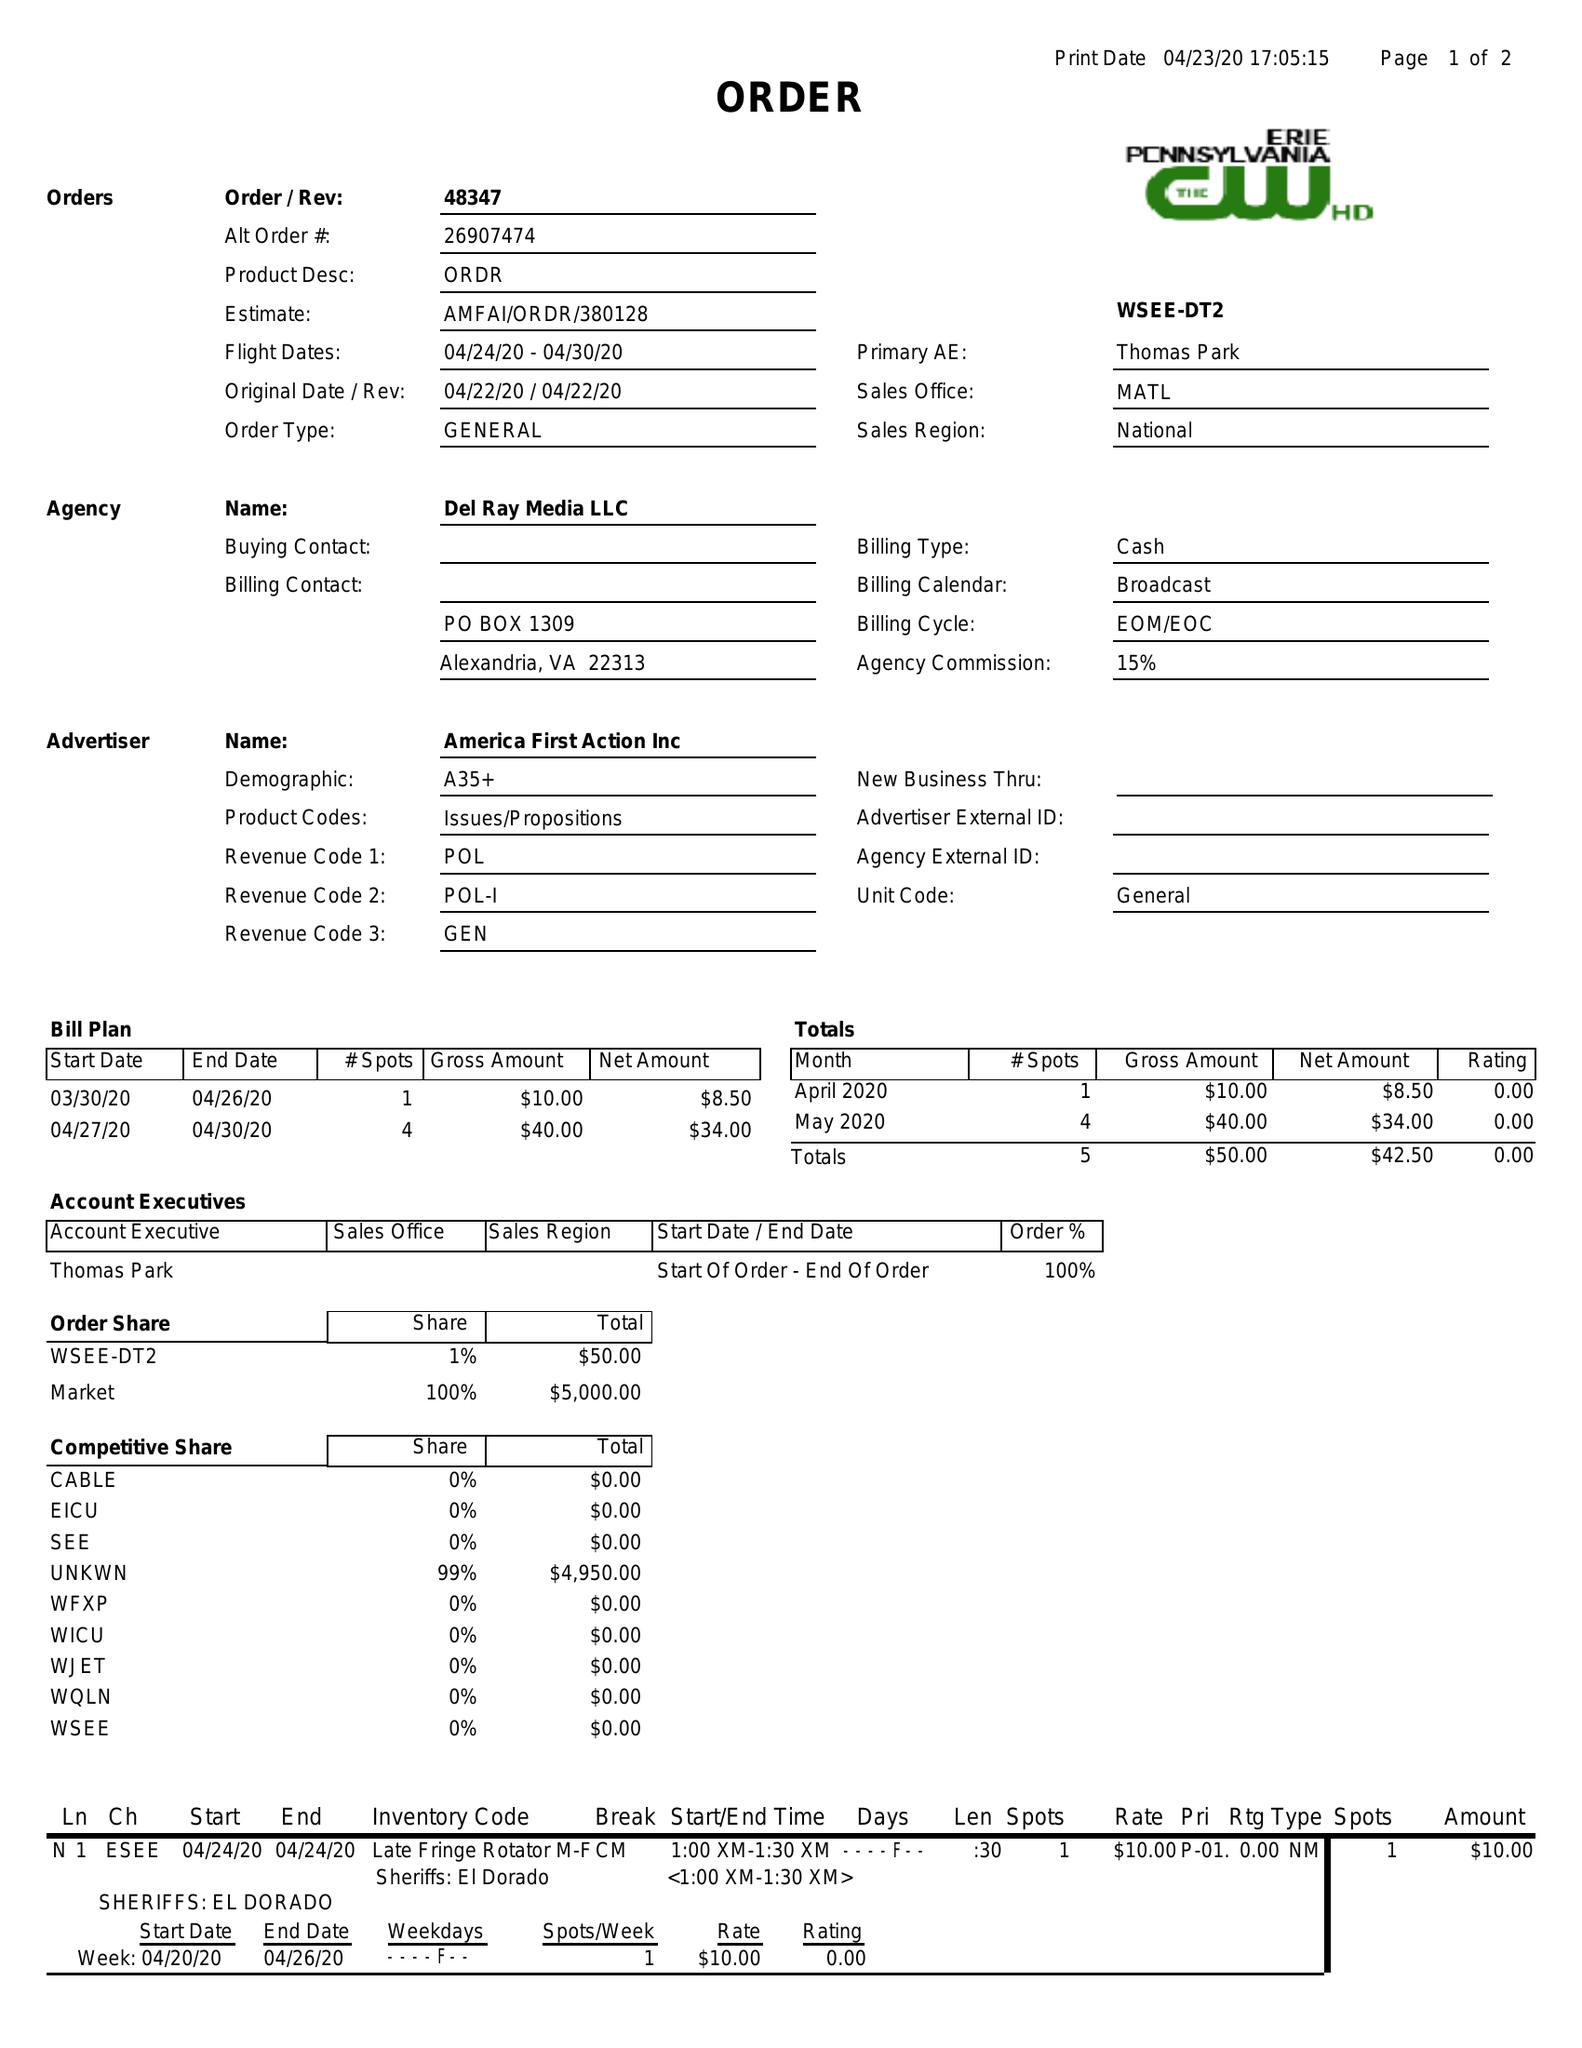What is the value for the advertiser?
Answer the question using a single word or phrase. AMERICA FIRST ACTION INC 